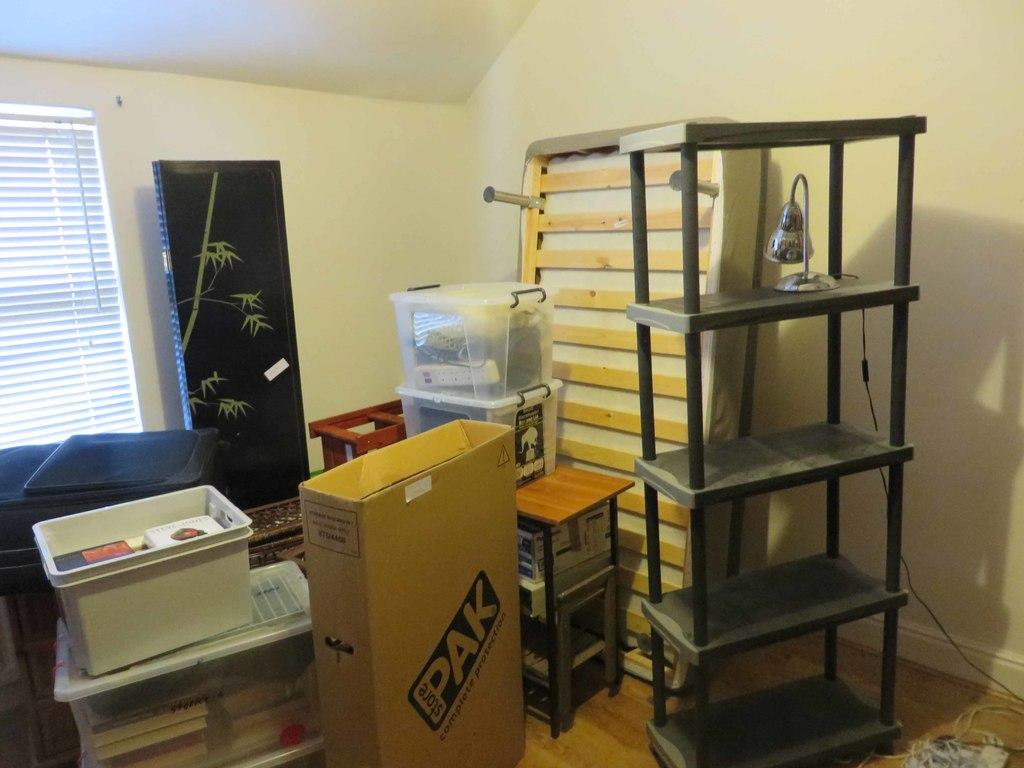<image>
Render a clear and concise summary of the photo. A room that looks packed for a moved with a box that has the label Pak. 